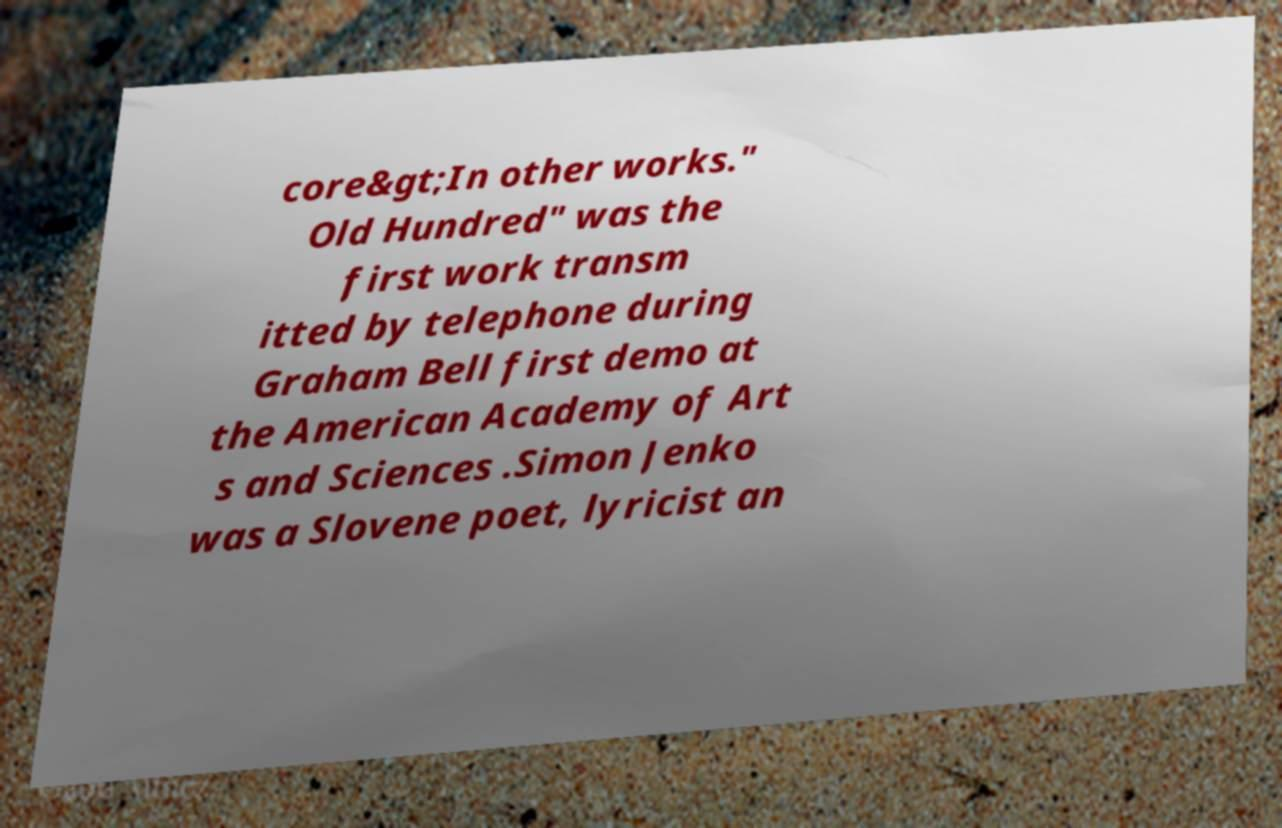Please identify and transcribe the text found in this image. core&gt;In other works." Old Hundred" was the first work transm itted by telephone during Graham Bell first demo at the American Academy of Art s and Sciences .Simon Jenko was a Slovene poet, lyricist an 